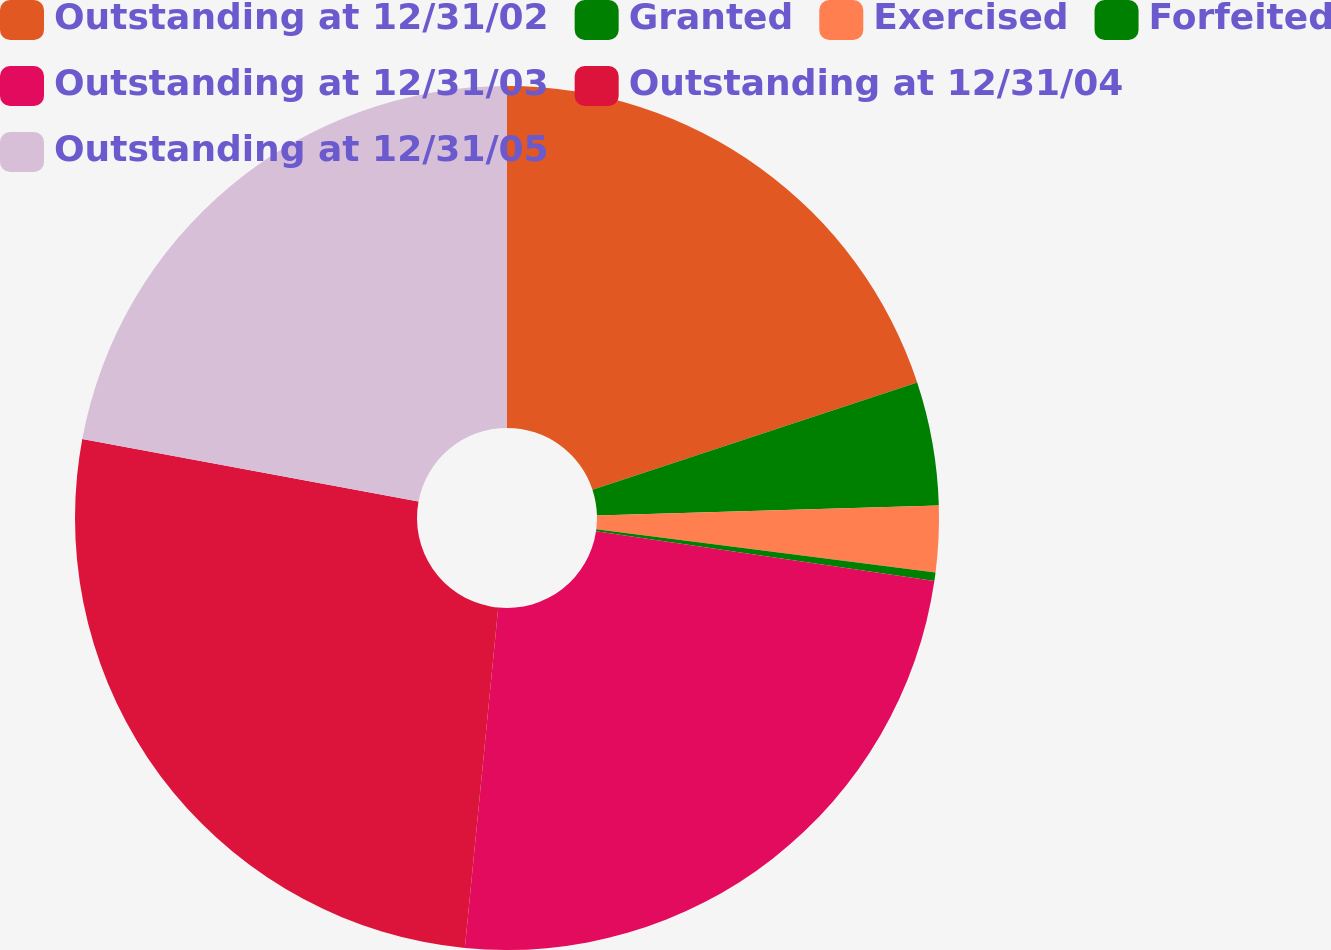<chart> <loc_0><loc_0><loc_500><loc_500><pie_chart><fcel>Outstanding at 12/31/02<fcel>Granted<fcel>Exercised<fcel>Forfeited<fcel>Outstanding at 12/31/03<fcel>Outstanding at 12/31/04<fcel>Outstanding at 12/31/05<nl><fcel>19.92%<fcel>4.62%<fcel>2.47%<fcel>0.32%<fcel>24.22%<fcel>26.37%<fcel>22.07%<nl></chart> 